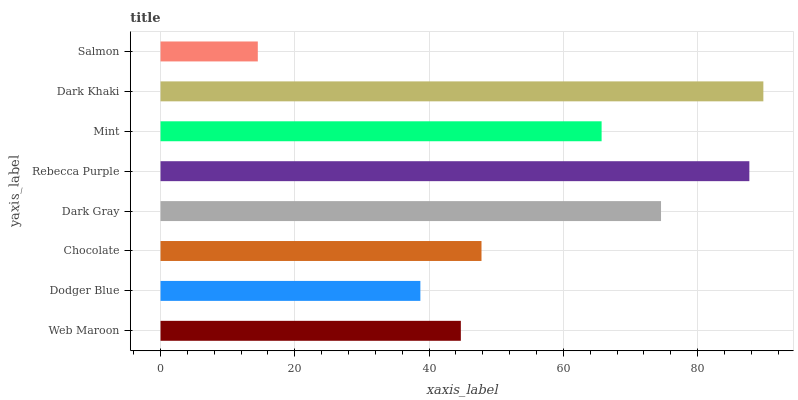Is Salmon the minimum?
Answer yes or no. Yes. Is Dark Khaki the maximum?
Answer yes or no. Yes. Is Dodger Blue the minimum?
Answer yes or no. No. Is Dodger Blue the maximum?
Answer yes or no. No. Is Web Maroon greater than Dodger Blue?
Answer yes or no. Yes. Is Dodger Blue less than Web Maroon?
Answer yes or no. Yes. Is Dodger Blue greater than Web Maroon?
Answer yes or no. No. Is Web Maroon less than Dodger Blue?
Answer yes or no. No. Is Mint the high median?
Answer yes or no. Yes. Is Chocolate the low median?
Answer yes or no. Yes. Is Web Maroon the high median?
Answer yes or no. No. Is Salmon the low median?
Answer yes or no. No. 